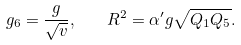<formula> <loc_0><loc_0><loc_500><loc_500>g _ { 6 } = \frac { g } { \sqrt { v } } , \quad R ^ { 2 } = \alpha ^ { \prime } g \sqrt { Q _ { 1 } Q _ { 5 } } .</formula> 